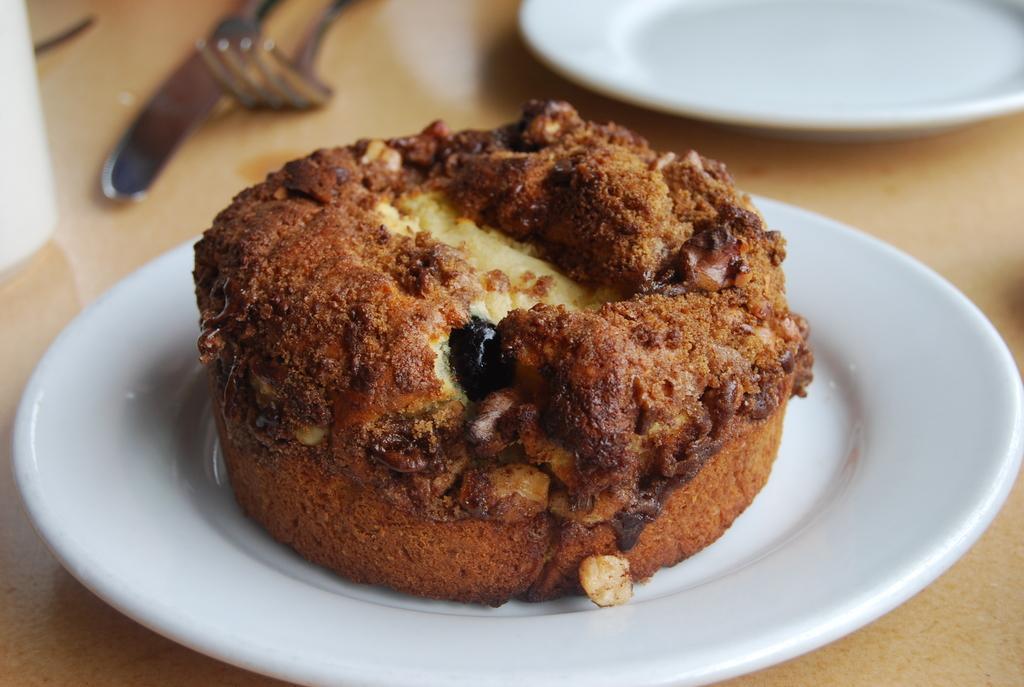Could you give a brief overview of what you see in this image? In this picture we see a brownie on a white plate kept on a table. 